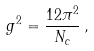Convert formula to latex. <formula><loc_0><loc_0><loc_500><loc_500>\ g ^ { 2 } = \frac { 1 2 \pi ^ { 2 } } { N _ { c } } \, ,</formula> 